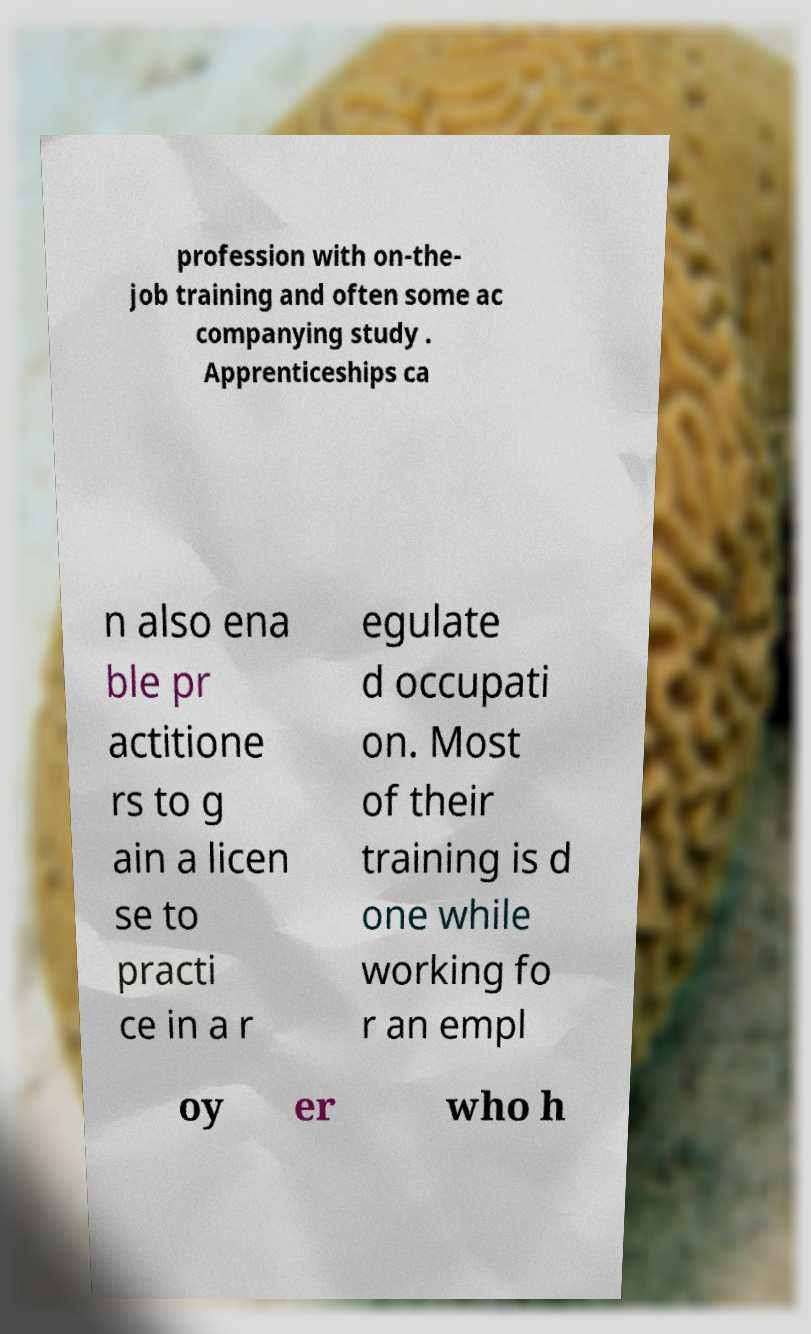Please identify and transcribe the text found in this image. profession with on-the- job training and often some ac companying study . Apprenticeships ca n also ena ble pr actitione rs to g ain a licen se to practi ce in a r egulate d occupati on. Most of their training is d one while working fo r an empl oy er who h 